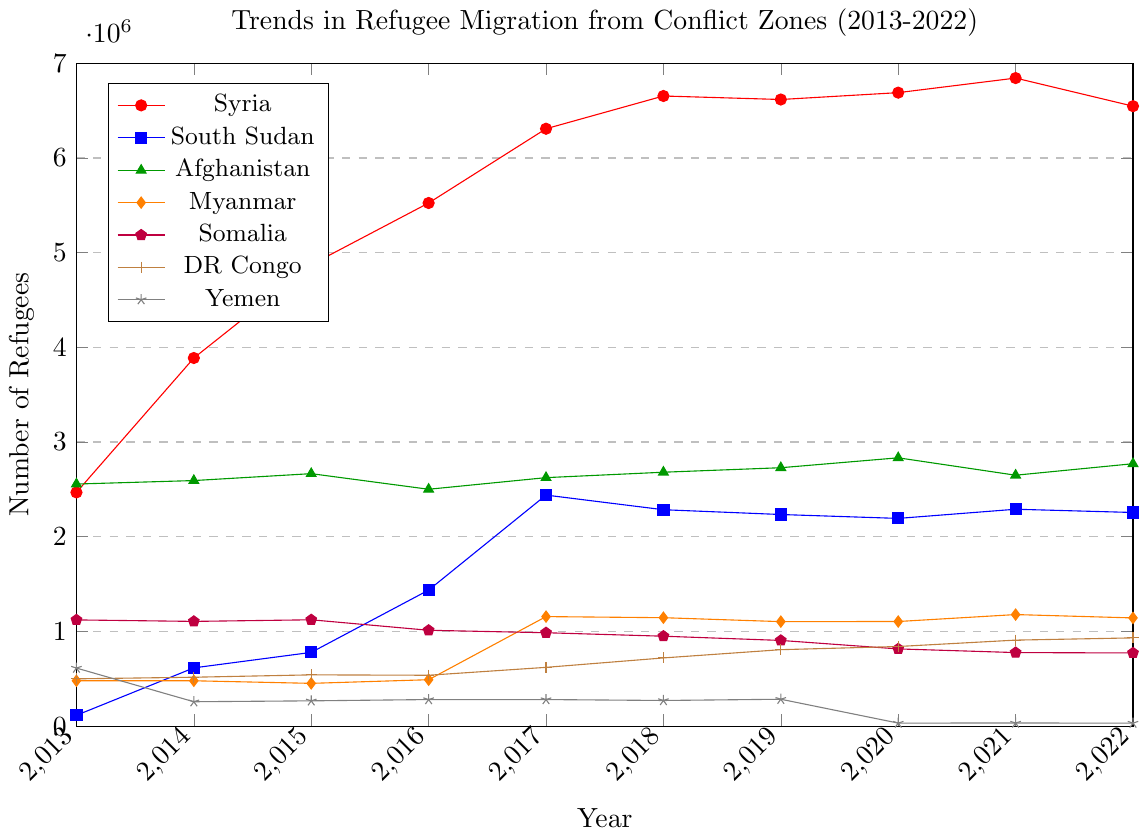Which country had the highest number of refugees in 2022? To find this answer, look at the values on the y-axis for each country in 2022. The line representing Syria's refugees reaches the highest point near 6.5 million.
Answer: Syria Which country experienced the largest increase in refugee numbers between 2013 and 2022? Calculate the difference between refugee numbers in 2022 and 2013 for each country. The increase in Syria's refugees from 2,468,369 in 2013 to 6,547,080 in 2022 is the largest.
Answer: Syria Did any country see a decline in refugee numbers from 2021 to 2022? Compare the refugee numbers in 2021 and 2022 for each country. Syria, South Sudan, Afghanistan, Myanmar, Somalia, and Yemen all had lower figures in 2022 compared to 2021.
Answer: Multiple countries Which country had the most stable refugee numbers over the decade? Judge stability by looking for the line with the least fluctuation over the ten years. Somalia's trend is relatively stable with only a slight decline over the years.
Answer: Somalia How many countries had over 500,000 refugees in any year? Look at each line and see which countries' refugee numbers exceed 500,000 at any point. Syria, South Sudan, Afghanistan, Myanmar, Somalia, DR Congo, and Yemen all did at some point.
Answer: 6 countries In which year did Myanmar see a significant spike in refugee numbers? Identify the year with a noticeable jump in Myanmar's line. In 2017, Myanmar's refugee number sharply increased, reaching a peak of 1,156,732.
Answer: 2017 Which two countries' refugee trends are most similar? Look at the lines that follow a similar pattern over the years. Afghanistan and Myanmar's lines show relatively similar fluctuations and trends from 2013 to 2022.
Answer: Afghanistan and Myanmar What is the average refugee count for DR Congo from 2013 to 2022? Sum DR Congo's refugee numbers across all years and then divide by the number of years. \( (499541 + 516562 + 541499 + 537473 + 620800 + 720311 + 807418 + 840974 + 908399 + 931968) / 10 = 692694.5 \)
Answer: 692,694.5 Is there any year when all countries saw an increase in refugee numbers compared to the previous year? Check the yearly progression for each country. There isn't a single year where all seven countries saw an increase compared to the previous year.
Answer: No Which year had the biggest single-year increase in the total number of refugees across all countries? Calculate the year-over-year differences and identify the largest. The increase from 2015 to 2016, particularly driven by Syria and South Sudan, seems the largest.
Answer: 2016 